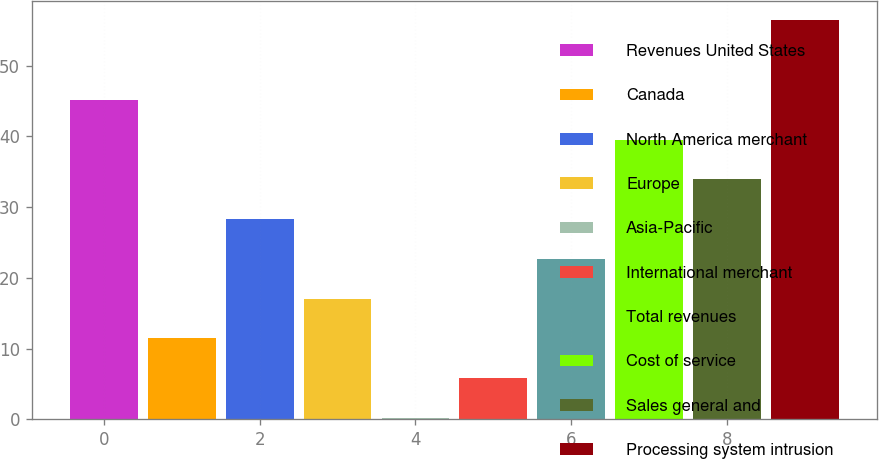Convert chart to OTSL. <chart><loc_0><loc_0><loc_500><loc_500><bar_chart><fcel>Revenues United States<fcel>Canada<fcel>North America merchant<fcel>Europe<fcel>Asia-Pacific<fcel>International merchant<fcel>Total revenues<fcel>Cost of service<fcel>Sales general and<fcel>Processing system intrusion<nl><fcel>45.16<fcel>11.44<fcel>28.3<fcel>17.06<fcel>0.2<fcel>5.82<fcel>22.68<fcel>39.54<fcel>33.92<fcel>56.4<nl></chart> 